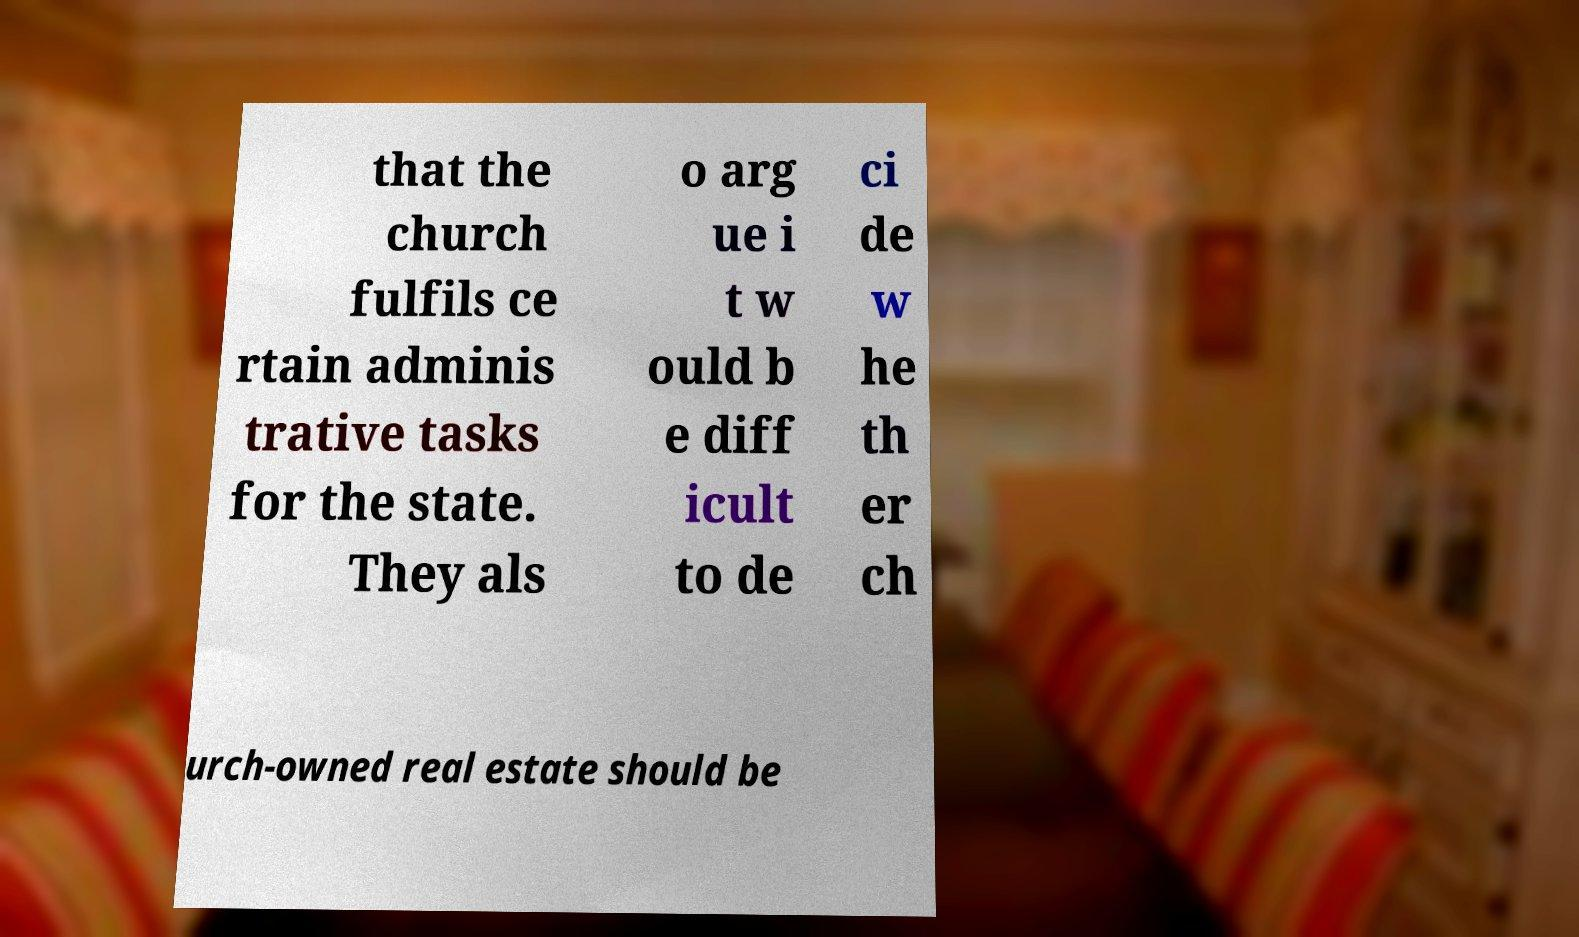Can you accurately transcribe the text from the provided image for me? that the church fulfils ce rtain adminis trative tasks for the state. They als o arg ue i t w ould b e diff icult to de ci de w he th er ch urch-owned real estate should be 